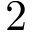<formula> <loc_0><loc_0><loc_500><loc_500>2</formula> 